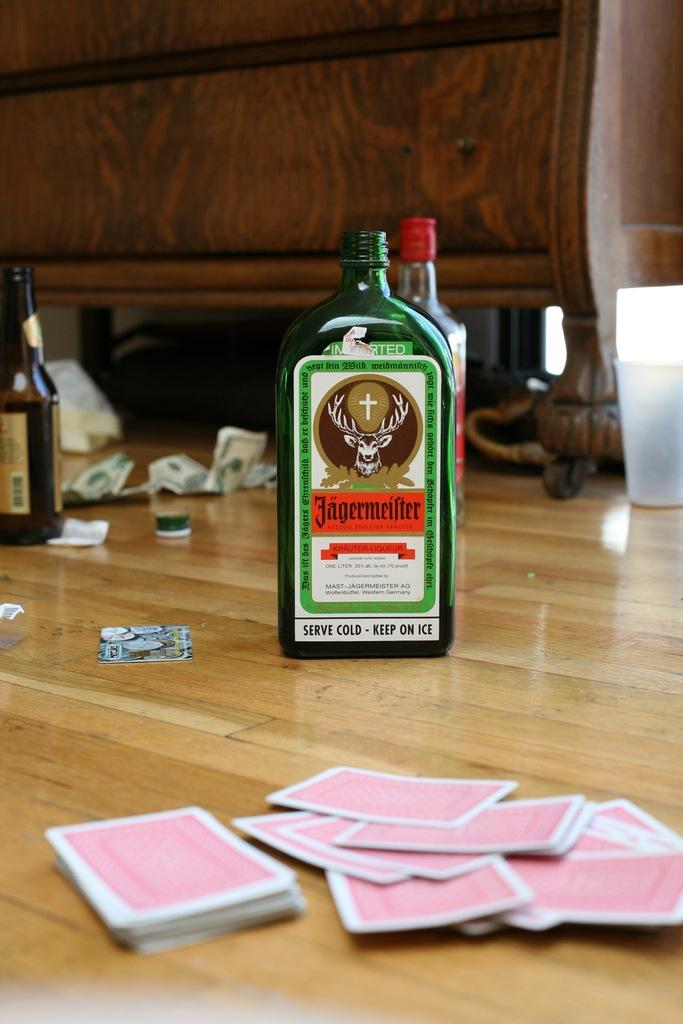<image>
Write a terse but informative summary of the picture. A bottle of Jägermeister is on a wooden table with some playing cards. 